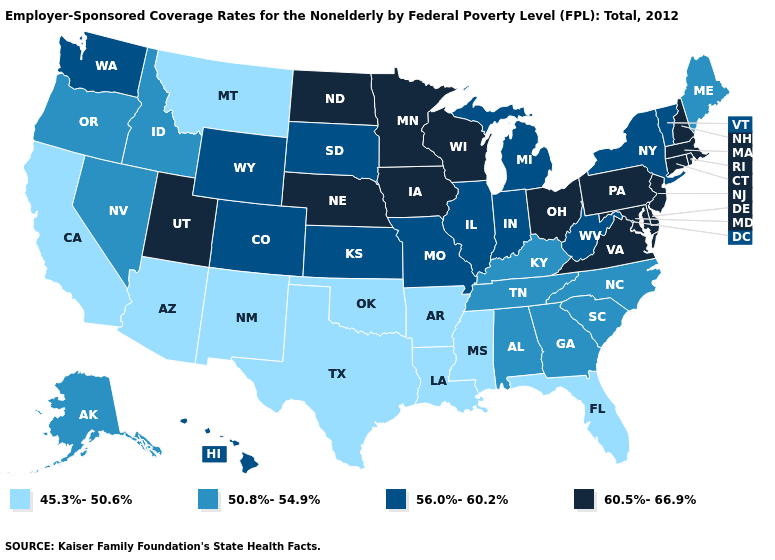What is the value of Indiana?
Short answer required. 56.0%-60.2%. What is the lowest value in states that border Pennsylvania?
Short answer required. 56.0%-60.2%. What is the highest value in states that border North Carolina?
Quick response, please. 60.5%-66.9%. What is the value of Louisiana?
Give a very brief answer. 45.3%-50.6%. Name the states that have a value in the range 56.0%-60.2%?
Short answer required. Colorado, Hawaii, Illinois, Indiana, Kansas, Michigan, Missouri, New York, South Dakota, Vermont, Washington, West Virginia, Wyoming. Which states have the lowest value in the USA?
Answer briefly. Arizona, Arkansas, California, Florida, Louisiana, Mississippi, Montana, New Mexico, Oklahoma, Texas. What is the lowest value in states that border Tennessee?
Answer briefly. 45.3%-50.6%. Is the legend a continuous bar?
Quick response, please. No. What is the highest value in the USA?
Concise answer only. 60.5%-66.9%. Name the states that have a value in the range 60.5%-66.9%?
Keep it brief. Connecticut, Delaware, Iowa, Maryland, Massachusetts, Minnesota, Nebraska, New Hampshire, New Jersey, North Dakota, Ohio, Pennsylvania, Rhode Island, Utah, Virginia, Wisconsin. Among the states that border New Jersey , which have the lowest value?
Give a very brief answer. New York. What is the value of Virginia?
Write a very short answer. 60.5%-66.9%. Which states hav the highest value in the West?
Answer briefly. Utah. 